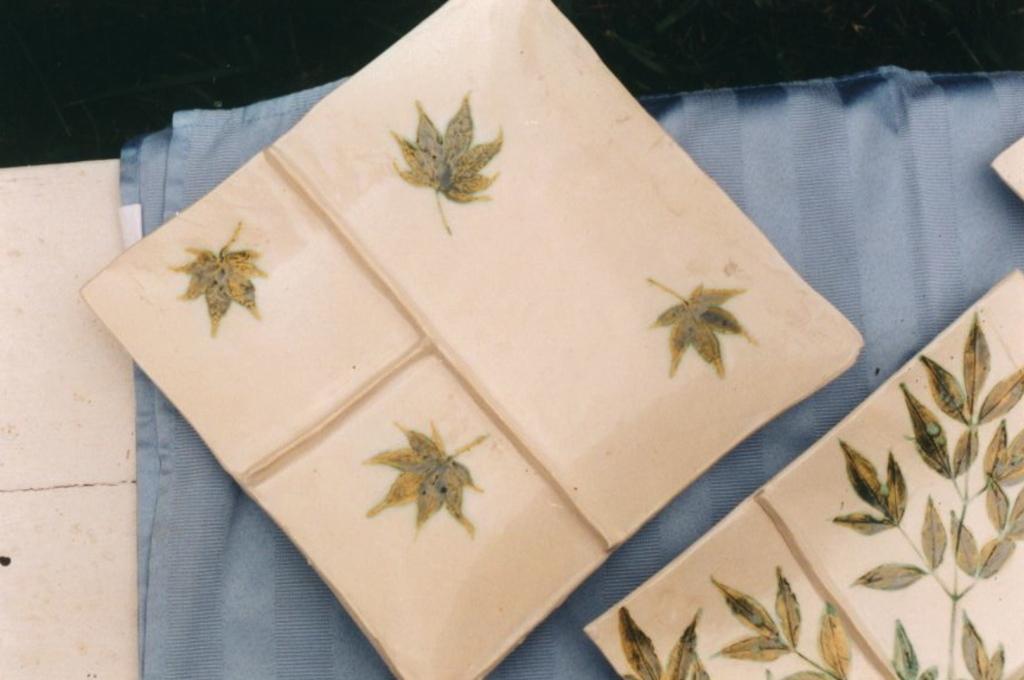Describe this image in one or two sentences. In this image, I can see the clothes on an object. 